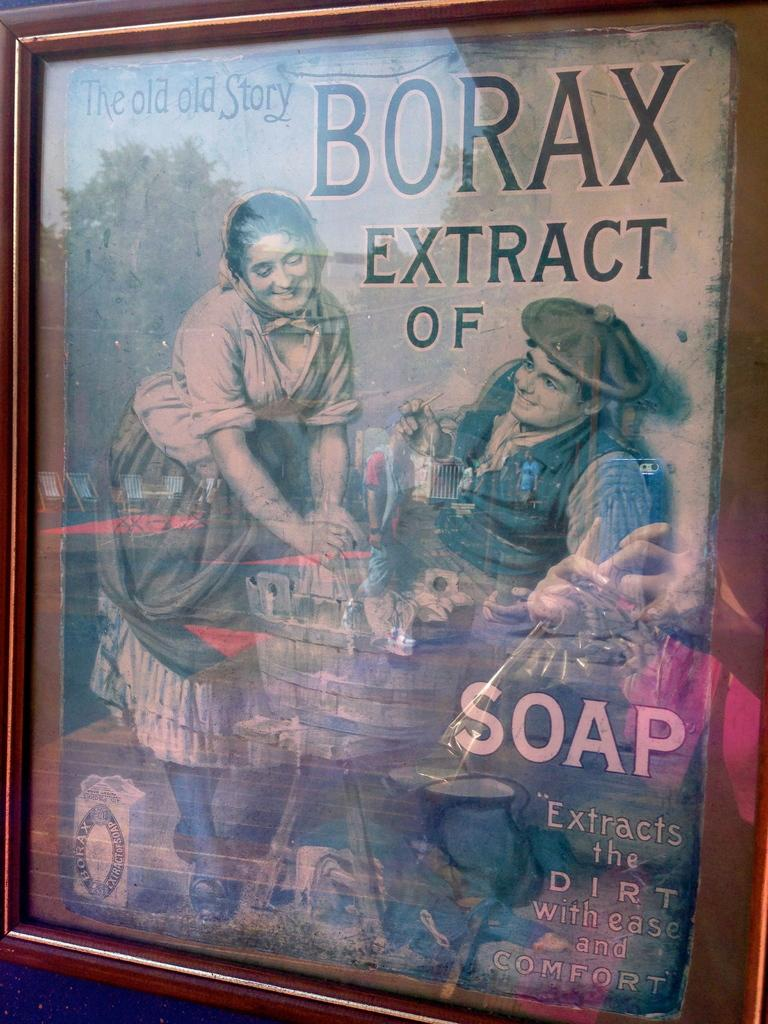<image>
Provide a brief description of the given image. Book which is called the old story of Borax 